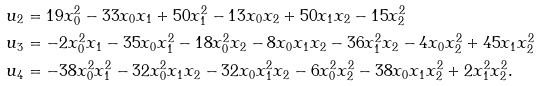<formula> <loc_0><loc_0><loc_500><loc_500>u _ { 2 } & = 1 9 x _ { 0 } ^ { 2 } - 3 3 x _ { 0 } x _ { 1 } + 5 0 x _ { 1 } ^ { 2 } - 1 3 x _ { 0 } x _ { 2 } + 5 0 x _ { 1 } x _ { 2 } - 1 5 x _ { 2 } ^ { 2 } \\ u _ { 3 } & = - 2 x _ { 0 } ^ { 2 } x _ { 1 } - 3 5 x _ { 0 } x _ { 1 } ^ { 2 } - 1 8 x _ { 0 } ^ { 2 } x _ { 2 } - 8 x _ { 0 } x _ { 1 } x _ { 2 } - 3 6 x _ { 1 } ^ { 2 } x _ { 2 } - 4 x _ { 0 } x _ { 2 } ^ { 2 } + 4 5 x _ { 1 } x _ { 2 } ^ { 2 } \\ u _ { 4 } & = - 3 8 x _ { 0 } ^ { 2 } x _ { 1 } ^ { 2 } - 3 2 x _ { 0 } ^ { 2 } x _ { 1 } x _ { 2 } - 3 2 x _ { 0 } x _ { 1 } ^ { 2 } x _ { 2 } - 6 x _ { 0 } ^ { 2 } x _ { 2 } ^ { 2 } - 3 8 x _ { 0 } x _ { 1 } x _ { 2 } ^ { 2 } + 2 x _ { 1 } ^ { 2 } x _ { 2 } ^ { 2 } .</formula> 